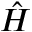Convert formula to latex. <formula><loc_0><loc_0><loc_500><loc_500>\hat { H }</formula> 